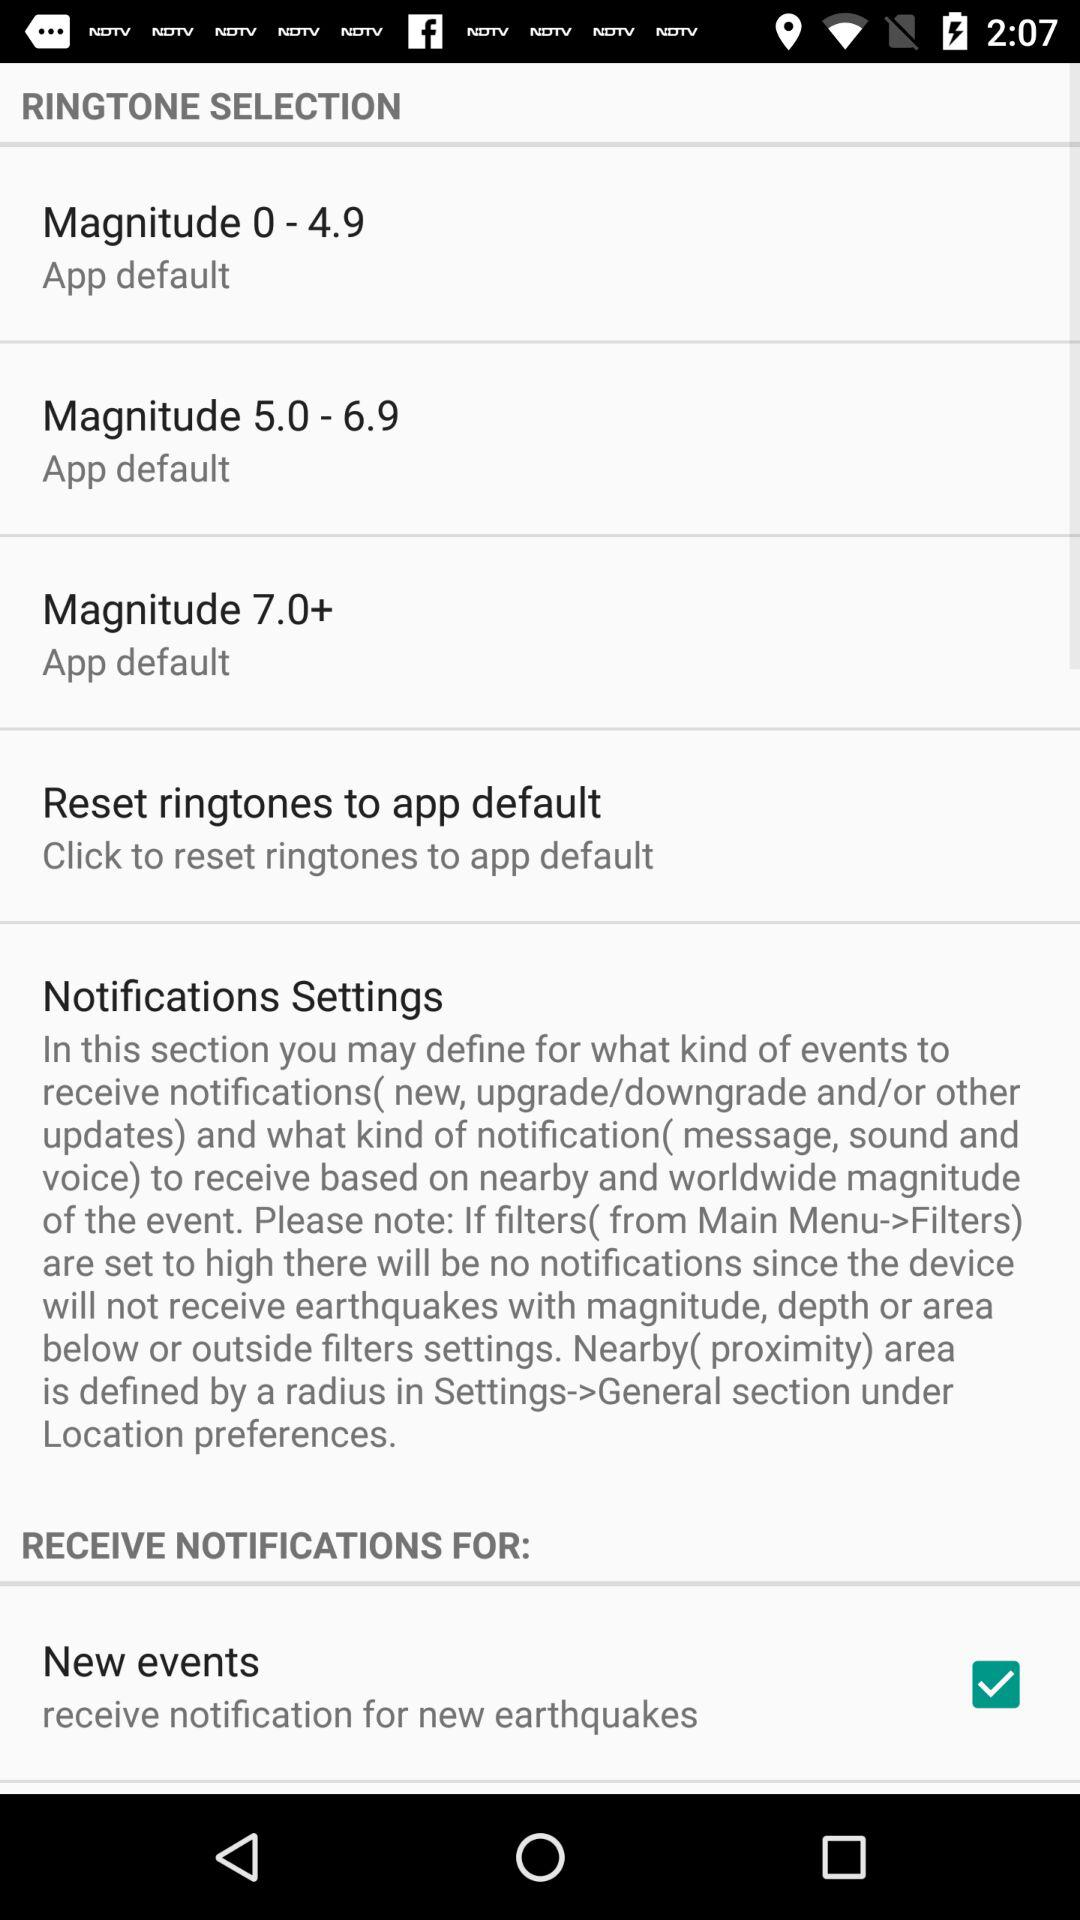What are the magnitude scales for the ringtone selection? The magnitude scales are "Magnitude 0–4.9", "Magnitude 5.0–6.9", and "Magnitude 7.0+". 